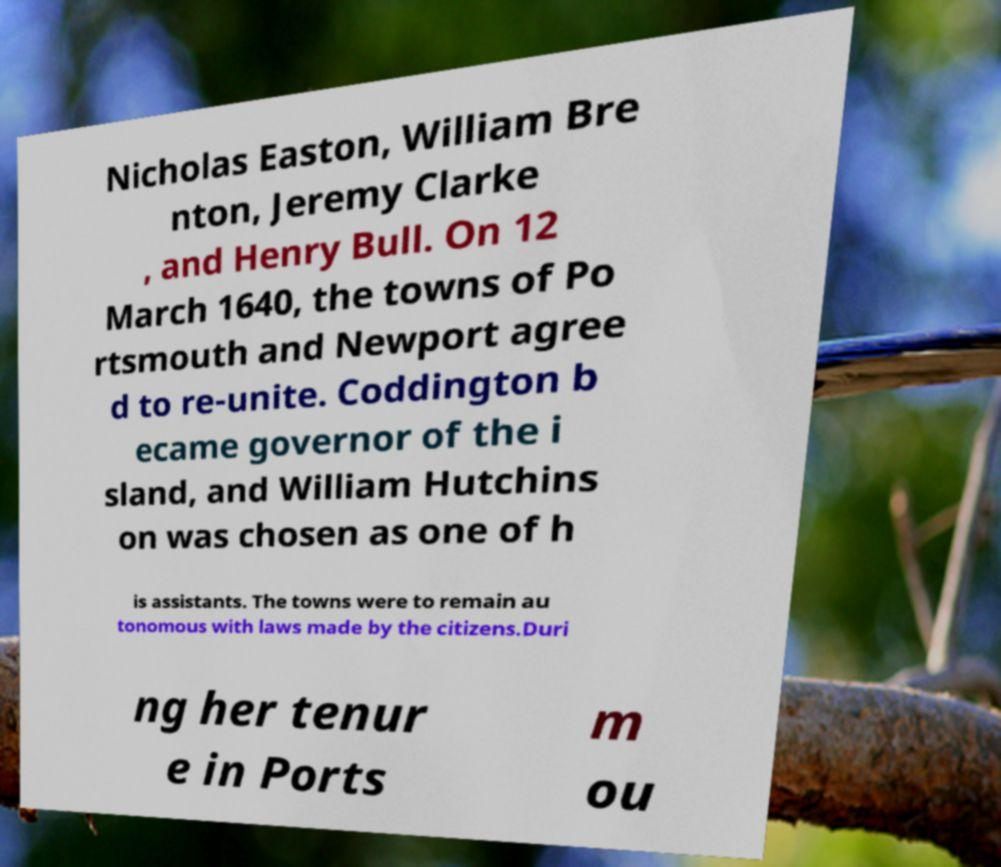Can you read and provide the text displayed in the image?This photo seems to have some interesting text. Can you extract and type it out for me? Nicholas Easton, William Bre nton, Jeremy Clarke , and Henry Bull. On 12 March 1640, the towns of Po rtsmouth and Newport agree d to re-unite. Coddington b ecame governor of the i sland, and William Hutchins on was chosen as one of h is assistants. The towns were to remain au tonomous with laws made by the citizens.Duri ng her tenur e in Ports m ou 